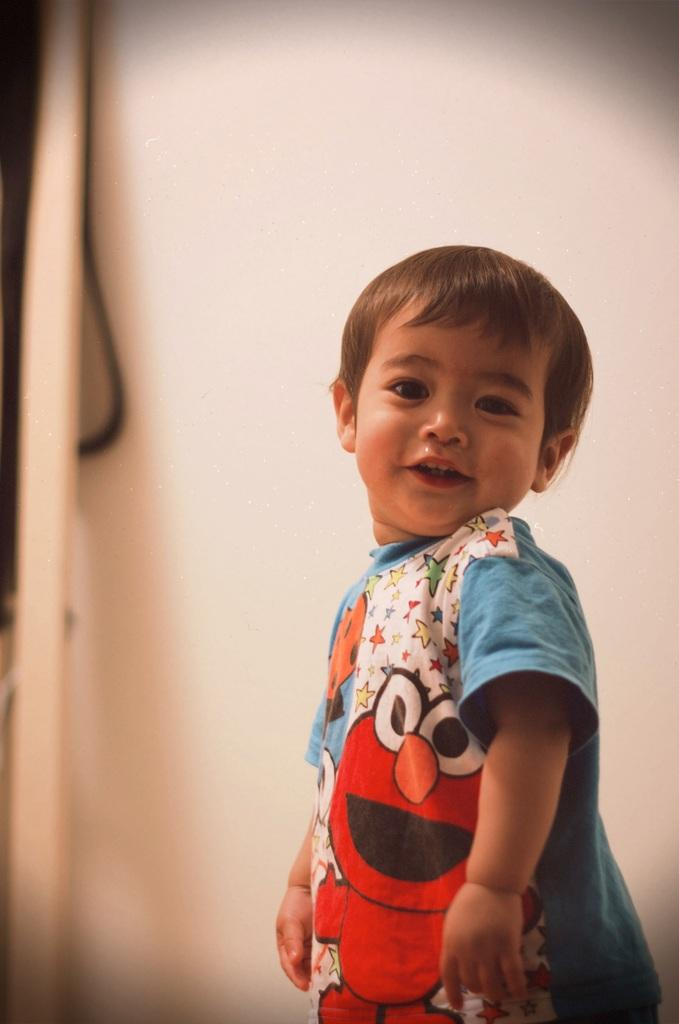What is the main subject of the picture? The main subject of the picture is a boy. Where is the boy located in the image? The boy is in the middle of the image. What is the boy wearing in the picture? The boy is wearing a t-shirt. What type of cow can be seen in the picture? There is no cow present in the picture; it features a boy in the middle of the image. What discovery did the boy make in the picture? There is no indication of a discovery in the picture; it simply shows a boy wearing a t-shirt. 